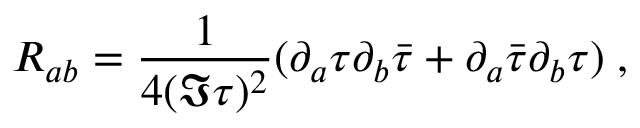Convert formula to latex. <formula><loc_0><loc_0><loc_500><loc_500>R _ { a b } = \frac { 1 } { 4 ( \Im \tau ) ^ { 2 } } ( \partial _ { a } \tau \partial _ { b } \bar { \tau } + \partial _ { a } \bar { \tau } \partial _ { b } \tau ) \, ,</formula> 